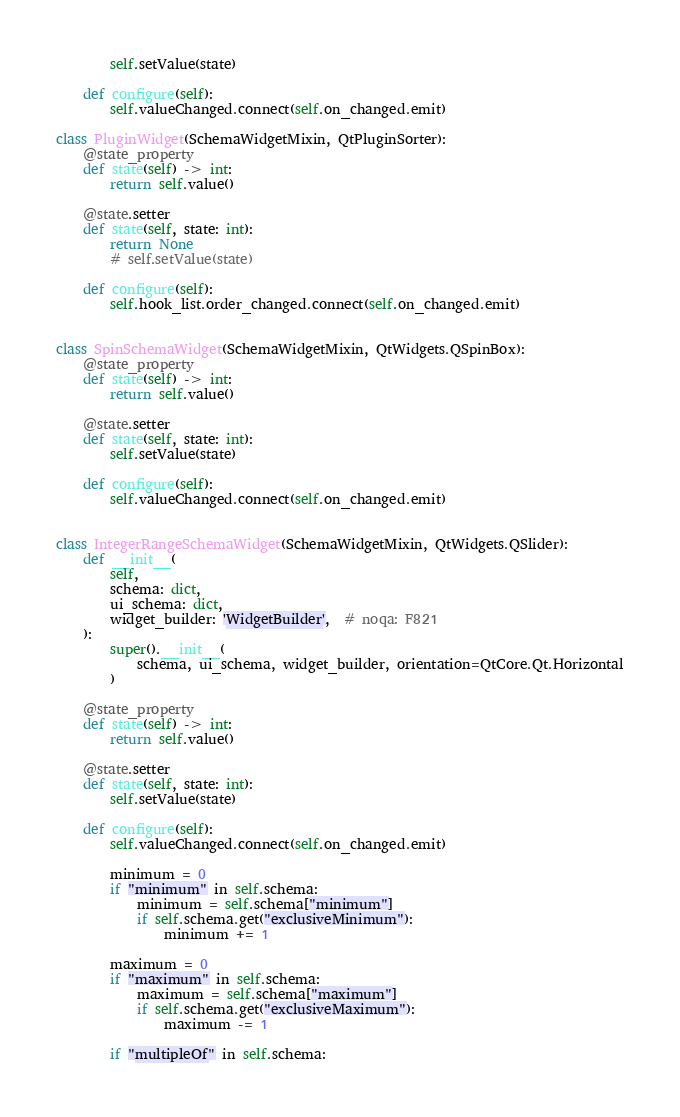<code> <loc_0><loc_0><loc_500><loc_500><_Python_>        self.setValue(state)

    def configure(self):
        self.valueChanged.connect(self.on_changed.emit)

class PluginWidget(SchemaWidgetMixin, QtPluginSorter):
    @state_property
    def state(self) -> int:
        return self.value()

    @state.setter
    def state(self, state: int):
        return None
        # self.setValue(state)

    def configure(self):
        self.hook_list.order_changed.connect(self.on_changed.emit)


class SpinSchemaWidget(SchemaWidgetMixin, QtWidgets.QSpinBox):
    @state_property
    def state(self) -> int:
        return self.value()

    @state.setter
    def state(self, state: int):
        self.setValue(state)

    def configure(self):
        self.valueChanged.connect(self.on_changed.emit)


class IntegerRangeSchemaWidget(SchemaWidgetMixin, QtWidgets.QSlider):
    def __init__(
        self,
        schema: dict,
        ui_schema: dict,
        widget_builder: 'WidgetBuilder',  # noqa: F821
    ):
        super().__init__(
            schema, ui_schema, widget_builder, orientation=QtCore.Qt.Horizontal
        )

    @state_property
    def state(self) -> int:
        return self.value()

    @state.setter
    def state(self, state: int):
        self.setValue(state)

    def configure(self):
        self.valueChanged.connect(self.on_changed.emit)

        minimum = 0
        if "minimum" in self.schema:
            minimum = self.schema["minimum"]
            if self.schema.get("exclusiveMinimum"):
                minimum += 1

        maximum = 0
        if "maximum" in self.schema:
            maximum = self.schema["maximum"]
            if self.schema.get("exclusiveMaximum"):
                maximum -= 1

        if "multipleOf" in self.schema:</code> 